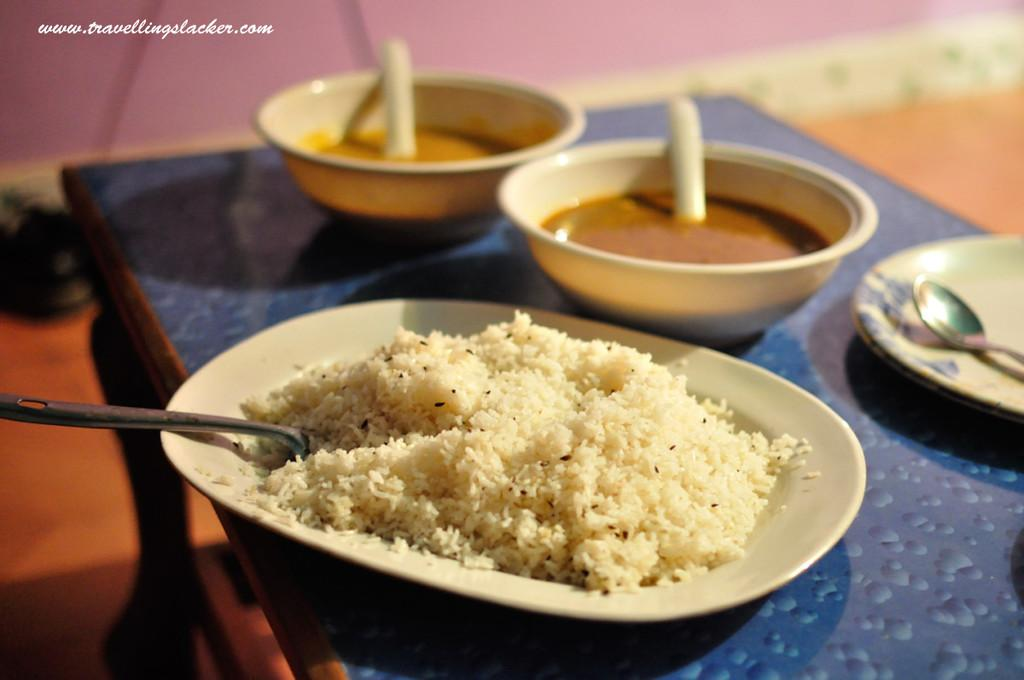How many bowls are present in the image? There are 2 bowls in the image. How many plates are present in the image? There are 2 plates in the image. What can be inferred about the presence of food in the image? There is food visible in the image. How many spoons are present in the image? There are 2 spoons in the image. Where are these items located in the image? All these items are on a table. Is there a jar visible in the image? No, there is no jar present in the image. How many bowls would there be if we added a fifth one to the image? There would be 3 bowls if a fifth one were added to the image, but as per the given facts, there are only 2 bowls present. 